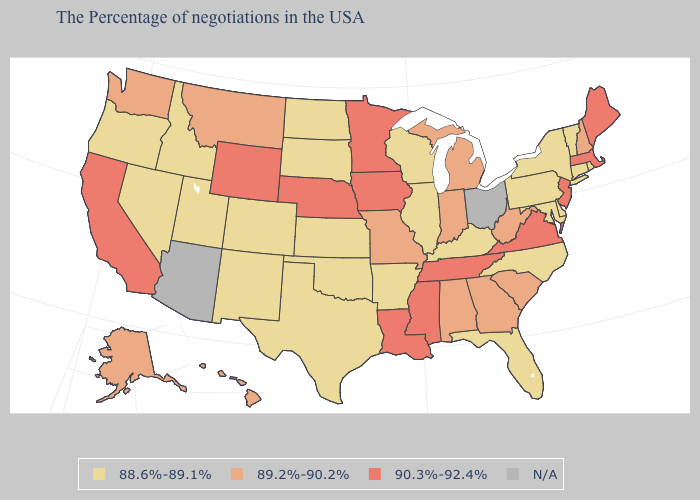Name the states that have a value in the range N/A?
Answer briefly. Ohio, Arizona. Name the states that have a value in the range N/A?
Quick response, please. Ohio, Arizona. Which states have the highest value in the USA?
Short answer required. Maine, Massachusetts, New Jersey, Virginia, Tennessee, Mississippi, Louisiana, Minnesota, Iowa, Nebraska, Wyoming, California. Among the states that border Maine , which have the lowest value?
Write a very short answer. New Hampshire. What is the lowest value in the USA?
Keep it brief. 88.6%-89.1%. Name the states that have a value in the range 90.3%-92.4%?
Keep it brief. Maine, Massachusetts, New Jersey, Virginia, Tennessee, Mississippi, Louisiana, Minnesota, Iowa, Nebraska, Wyoming, California. Name the states that have a value in the range N/A?
Answer briefly. Ohio, Arizona. What is the highest value in the MidWest ?
Keep it brief. 90.3%-92.4%. What is the highest value in the MidWest ?
Short answer required. 90.3%-92.4%. What is the value of Florida?
Quick response, please. 88.6%-89.1%. Among the states that border Utah , does Nevada have the lowest value?
Concise answer only. Yes. Name the states that have a value in the range 89.2%-90.2%?
Write a very short answer. New Hampshire, South Carolina, West Virginia, Georgia, Michigan, Indiana, Alabama, Missouri, Montana, Washington, Alaska, Hawaii. Does the first symbol in the legend represent the smallest category?
Keep it brief. Yes. Name the states that have a value in the range 88.6%-89.1%?
Give a very brief answer. Rhode Island, Vermont, Connecticut, New York, Delaware, Maryland, Pennsylvania, North Carolina, Florida, Kentucky, Wisconsin, Illinois, Arkansas, Kansas, Oklahoma, Texas, South Dakota, North Dakota, Colorado, New Mexico, Utah, Idaho, Nevada, Oregon. 